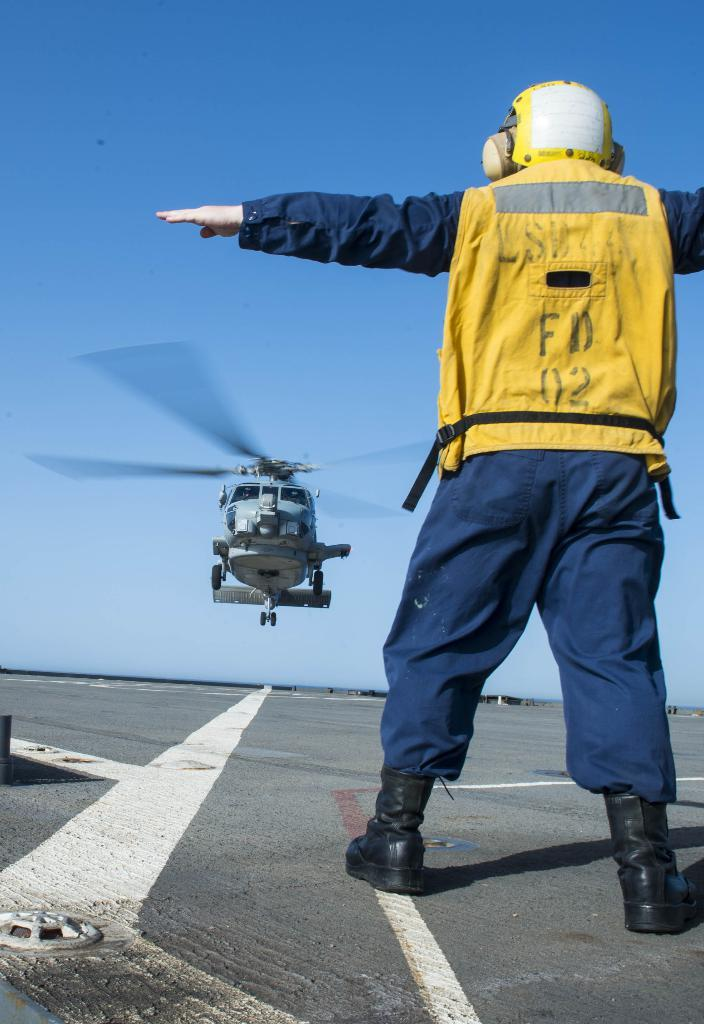Provide a one-sentence caption for the provided image. A helicopter director labeled FD 02 directs a chopper in landing. 